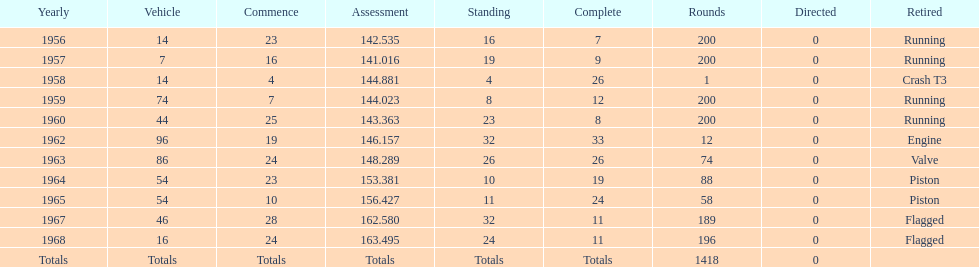Which year is the last qual on the chart 1968. 